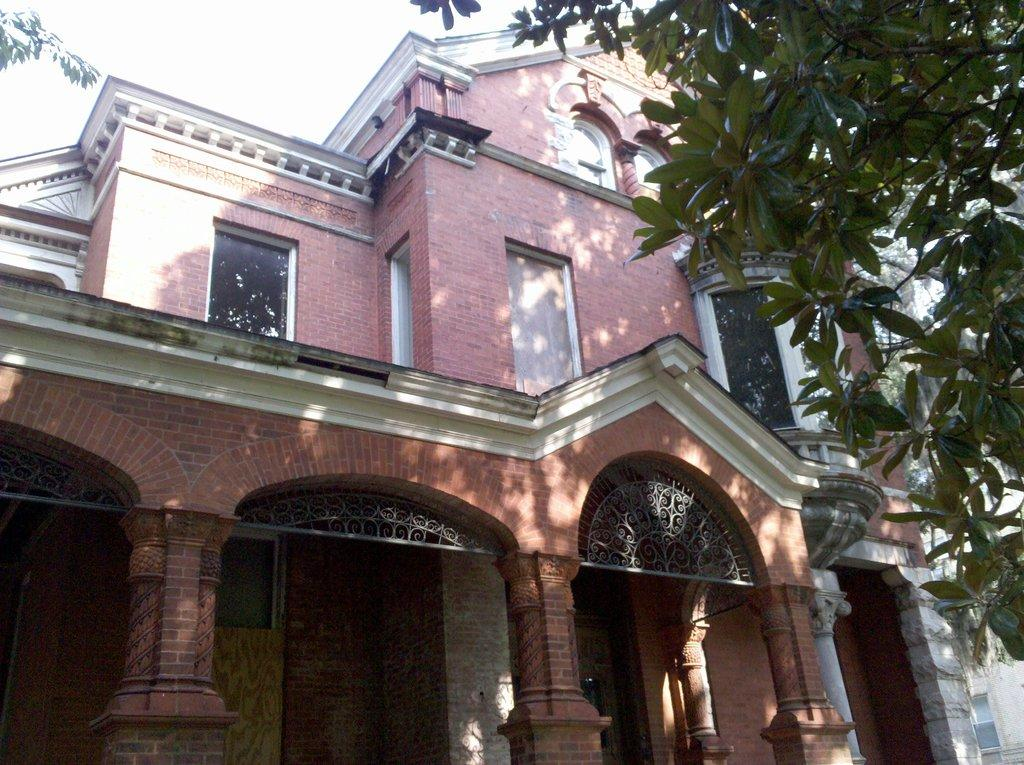What type of material is used to construct the building in the image? The building in the image is made of bricks. What architectural feature can be seen on the building? The building has pillars. What type of vegetation is on the right side of the image? There is a tree on the right side of the image. What is visible at the top of the image? The sky is visible at the top of the image. What type of sheet is draped over the tree in the image? There is no sheet present in the image; it features a tree and a brick building with pillars. 